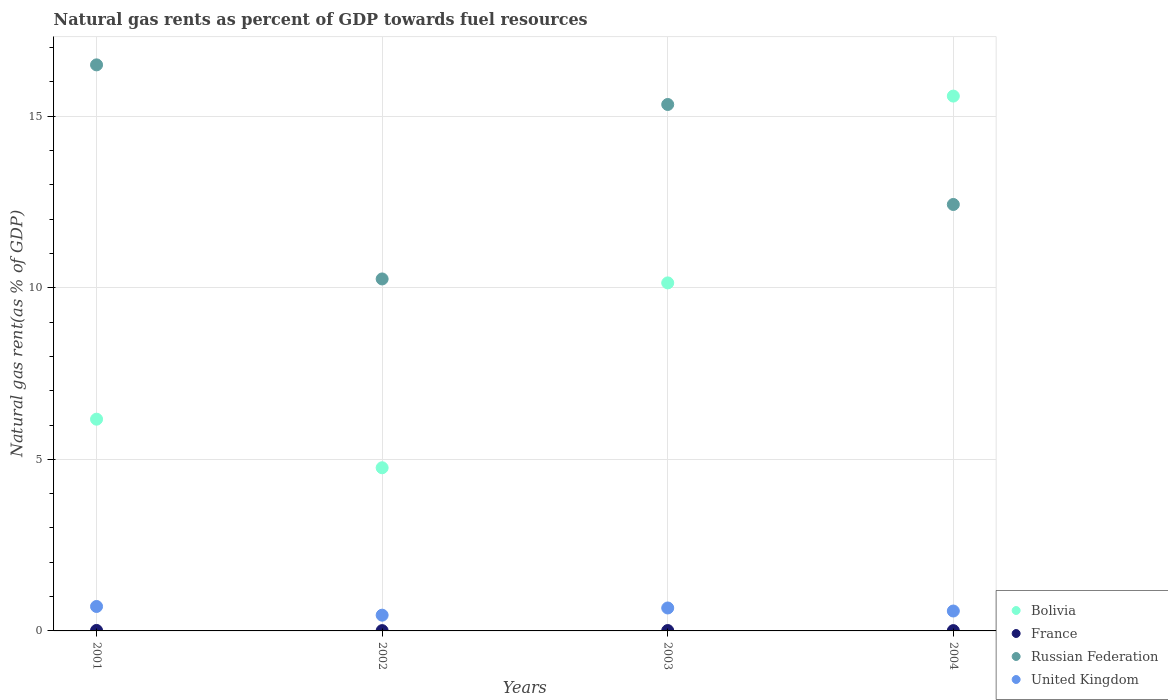Is the number of dotlines equal to the number of legend labels?
Give a very brief answer. Yes. What is the natural gas rent in Bolivia in 2001?
Keep it short and to the point. 6.17. Across all years, what is the maximum natural gas rent in United Kingdom?
Provide a short and direct response. 0.71. Across all years, what is the minimum natural gas rent in United Kingdom?
Your answer should be very brief. 0.46. In which year was the natural gas rent in Russian Federation maximum?
Offer a very short reply. 2001. What is the total natural gas rent in France in the graph?
Make the answer very short. 0.04. What is the difference between the natural gas rent in France in 2001 and that in 2003?
Offer a terse response. 0. What is the difference between the natural gas rent in Russian Federation in 2004 and the natural gas rent in United Kingdom in 2002?
Your answer should be compact. 11.97. What is the average natural gas rent in Bolivia per year?
Provide a short and direct response. 9.16. In the year 2002, what is the difference between the natural gas rent in United Kingdom and natural gas rent in Russian Federation?
Ensure brevity in your answer.  -9.8. In how many years, is the natural gas rent in France greater than 5 %?
Your answer should be very brief. 0. What is the ratio of the natural gas rent in Bolivia in 2002 to that in 2004?
Keep it short and to the point. 0.31. Is the difference between the natural gas rent in United Kingdom in 2003 and 2004 greater than the difference between the natural gas rent in Russian Federation in 2003 and 2004?
Keep it short and to the point. No. What is the difference between the highest and the second highest natural gas rent in France?
Ensure brevity in your answer.  0. What is the difference between the highest and the lowest natural gas rent in Russian Federation?
Keep it short and to the point. 6.24. In how many years, is the natural gas rent in France greater than the average natural gas rent in France taken over all years?
Your response must be concise. 2. Is the sum of the natural gas rent in Bolivia in 2001 and 2004 greater than the maximum natural gas rent in Russian Federation across all years?
Your response must be concise. Yes. Is it the case that in every year, the sum of the natural gas rent in United Kingdom and natural gas rent in Russian Federation  is greater than the sum of natural gas rent in Bolivia and natural gas rent in France?
Your response must be concise. No. Is it the case that in every year, the sum of the natural gas rent in United Kingdom and natural gas rent in France  is greater than the natural gas rent in Russian Federation?
Ensure brevity in your answer.  No. Does the natural gas rent in France monotonically increase over the years?
Provide a succinct answer. No. How many years are there in the graph?
Give a very brief answer. 4. Does the graph contain any zero values?
Make the answer very short. No. Does the graph contain grids?
Your answer should be very brief. Yes. How are the legend labels stacked?
Offer a very short reply. Vertical. What is the title of the graph?
Ensure brevity in your answer.  Natural gas rents as percent of GDP towards fuel resources. What is the label or title of the X-axis?
Make the answer very short. Years. What is the label or title of the Y-axis?
Your answer should be very brief. Natural gas rent(as % of GDP). What is the Natural gas rent(as % of GDP) in Bolivia in 2001?
Make the answer very short. 6.17. What is the Natural gas rent(as % of GDP) in France in 2001?
Give a very brief answer. 0.01. What is the Natural gas rent(as % of GDP) in Russian Federation in 2001?
Offer a terse response. 16.5. What is the Natural gas rent(as % of GDP) of United Kingdom in 2001?
Offer a terse response. 0.71. What is the Natural gas rent(as % of GDP) in Bolivia in 2002?
Provide a succinct answer. 4.76. What is the Natural gas rent(as % of GDP) in France in 2002?
Offer a very short reply. 0.01. What is the Natural gas rent(as % of GDP) of Russian Federation in 2002?
Give a very brief answer. 10.26. What is the Natural gas rent(as % of GDP) in United Kingdom in 2002?
Ensure brevity in your answer.  0.46. What is the Natural gas rent(as % of GDP) of Bolivia in 2003?
Give a very brief answer. 10.14. What is the Natural gas rent(as % of GDP) in France in 2003?
Keep it short and to the point. 0.01. What is the Natural gas rent(as % of GDP) in Russian Federation in 2003?
Make the answer very short. 15.34. What is the Natural gas rent(as % of GDP) in United Kingdom in 2003?
Provide a short and direct response. 0.67. What is the Natural gas rent(as % of GDP) of Bolivia in 2004?
Keep it short and to the point. 15.59. What is the Natural gas rent(as % of GDP) in France in 2004?
Offer a terse response. 0.01. What is the Natural gas rent(as % of GDP) in Russian Federation in 2004?
Make the answer very short. 12.43. What is the Natural gas rent(as % of GDP) of United Kingdom in 2004?
Offer a very short reply. 0.58. Across all years, what is the maximum Natural gas rent(as % of GDP) in Bolivia?
Ensure brevity in your answer.  15.59. Across all years, what is the maximum Natural gas rent(as % of GDP) of France?
Provide a short and direct response. 0.01. Across all years, what is the maximum Natural gas rent(as % of GDP) in Russian Federation?
Give a very brief answer. 16.5. Across all years, what is the maximum Natural gas rent(as % of GDP) in United Kingdom?
Offer a very short reply. 0.71. Across all years, what is the minimum Natural gas rent(as % of GDP) of Bolivia?
Provide a succinct answer. 4.76. Across all years, what is the minimum Natural gas rent(as % of GDP) of France?
Make the answer very short. 0.01. Across all years, what is the minimum Natural gas rent(as % of GDP) in Russian Federation?
Make the answer very short. 10.26. Across all years, what is the minimum Natural gas rent(as % of GDP) of United Kingdom?
Keep it short and to the point. 0.46. What is the total Natural gas rent(as % of GDP) of Bolivia in the graph?
Ensure brevity in your answer.  36.66. What is the total Natural gas rent(as % of GDP) of France in the graph?
Keep it short and to the point. 0.04. What is the total Natural gas rent(as % of GDP) in Russian Federation in the graph?
Your response must be concise. 54.53. What is the total Natural gas rent(as % of GDP) in United Kingdom in the graph?
Your answer should be very brief. 2.42. What is the difference between the Natural gas rent(as % of GDP) in Bolivia in 2001 and that in 2002?
Offer a very short reply. 1.42. What is the difference between the Natural gas rent(as % of GDP) of France in 2001 and that in 2002?
Your answer should be very brief. 0.01. What is the difference between the Natural gas rent(as % of GDP) of Russian Federation in 2001 and that in 2002?
Your answer should be compact. 6.24. What is the difference between the Natural gas rent(as % of GDP) in United Kingdom in 2001 and that in 2002?
Your response must be concise. 0.25. What is the difference between the Natural gas rent(as % of GDP) of Bolivia in 2001 and that in 2003?
Provide a short and direct response. -3.97. What is the difference between the Natural gas rent(as % of GDP) of France in 2001 and that in 2003?
Give a very brief answer. 0. What is the difference between the Natural gas rent(as % of GDP) in Russian Federation in 2001 and that in 2003?
Provide a succinct answer. 1.15. What is the difference between the Natural gas rent(as % of GDP) of United Kingdom in 2001 and that in 2003?
Your answer should be very brief. 0.04. What is the difference between the Natural gas rent(as % of GDP) in Bolivia in 2001 and that in 2004?
Offer a very short reply. -9.42. What is the difference between the Natural gas rent(as % of GDP) of France in 2001 and that in 2004?
Keep it short and to the point. 0.01. What is the difference between the Natural gas rent(as % of GDP) of Russian Federation in 2001 and that in 2004?
Ensure brevity in your answer.  4.07. What is the difference between the Natural gas rent(as % of GDP) of United Kingdom in 2001 and that in 2004?
Keep it short and to the point. 0.13. What is the difference between the Natural gas rent(as % of GDP) of Bolivia in 2002 and that in 2003?
Your answer should be very brief. -5.39. What is the difference between the Natural gas rent(as % of GDP) in France in 2002 and that in 2003?
Provide a succinct answer. -0. What is the difference between the Natural gas rent(as % of GDP) of Russian Federation in 2002 and that in 2003?
Your answer should be compact. -5.08. What is the difference between the Natural gas rent(as % of GDP) in United Kingdom in 2002 and that in 2003?
Ensure brevity in your answer.  -0.21. What is the difference between the Natural gas rent(as % of GDP) in Bolivia in 2002 and that in 2004?
Ensure brevity in your answer.  -10.83. What is the difference between the Natural gas rent(as % of GDP) in Russian Federation in 2002 and that in 2004?
Ensure brevity in your answer.  -2.17. What is the difference between the Natural gas rent(as % of GDP) in United Kingdom in 2002 and that in 2004?
Provide a succinct answer. -0.12. What is the difference between the Natural gas rent(as % of GDP) in Bolivia in 2003 and that in 2004?
Offer a very short reply. -5.44. What is the difference between the Natural gas rent(as % of GDP) in France in 2003 and that in 2004?
Your response must be concise. 0. What is the difference between the Natural gas rent(as % of GDP) in Russian Federation in 2003 and that in 2004?
Provide a short and direct response. 2.91. What is the difference between the Natural gas rent(as % of GDP) of United Kingdom in 2003 and that in 2004?
Provide a succinct answer. 0.09. What is the difference between the Natural gas rent(as % of GDP) in Bolivia in 2001 and the Natural gas rent(as % of GDP) in France in 2002?
Provide a succinct answer. 6.16. What is the difference between the Natural gas rent(as % of GDP) of Bolivia in 2001 and the Natural gas rent(as % of GDP) of Russian Federation in 2002?
Your response must be concise. -4.09. What is the difference between the Natural gas rent(as % of GDP) in Bolivia in 2001 and the Natural gas rent(as % of GDP) in United Kingdom in 2002?
Provide a succinct answer. 5.71. What is the difference between the Natural gas rent(as % of GDP) of France in 2001 and the Natural gas rent(as % of GDP) of Russian Federation in 2002?
Offer a very short reply. -10.24. What is the difference between the Natural gas rent(as % of GDP) of France in 2001 and the Natural gas rent(as % of GDP) of United Kingdom in 2002?
Offer a terse response. -0.44. What is the difference between the Natural gas rent(as % of GDP) of Russian Federation in 2001 and the Natural gas rent(as % of GDP) of United Kingdom in 2002?
Keep it short and to the point. 16.04. What is the difference between the Natural gas rent(as % of GDP) in Bolivia in 2001 and the Natural gas rent(as % of GDP) in France in 2003?
Keep it short and to the point. 6.16. What is the difference between the Natural gas rent(as % of GDP) of Bolivia in 2001 and the Natural gas rent(as % of GDP) of Russian Federation in 2003?
Give a very brief answer. -9.17. What is the difference between the Natural gas rent(as % of GDP) in Bolivia in 2001 and the Natural gas rent(as % of GDP) in United Kingdom in 2003?
Provide a succinct answer. 5.5. What is the difference between the Natural gas rent(as % of GDP) of France in 2001 and the Natural gas rent(as % of GDP) of Russian Federation in 2003?
Your answer should be very brief. -15.33. What is the difference between the Natural gas rent(as % of GDP) of France in 2001 and the Natural gas rent(as % of GDP) of United Kingdom in 2003?
Make the answer very short. -0.65. What is the difference between the Natural gas rent(as % of GDP) of Russian Federation in 2001 and the Natural gas rent(as % of GDP) of United Kingdom in 2003?
Offer a terse response. 15.83. What is the difference between the Natural gas rent(as % of GDP) in Bolivia in 2001 and the Natural gas rent(as % of GDP) in France in 2004?
Provide a short and direct response. 6.16. What is the difference between the Natural gas rent(as % of GDP) in Bolivia in 2001 and the Natural gas rent(as % of GDP) in Russian Federation in 2004?
Provide a short and direct response. -6.26. What is the difference between the Natural gas rent(as % of GDP) in Bolivia in 2001 and the Natural gas rent(as % of GDP) in United Kingdom in 2004?
Make the answer very short. 5.59. What is the difference between the Natural gas rent(as % of GDP) in France in 2001 and the Natural gas rent(as % of GDP) in Russian Federation in 2004?
Provide a succinct answer. -12.41. What is the difference between the Natural gas rent(as % of GDP) in France in 2001 and the Natural gas rent(as % of GDP) in United Kingdom in 2004?
Give a very brief answer. -0.57. What is the difference between the Natural gas rent(as % of GDP) of Russian Federation in 2001 and the Natural gas rent(as % of GDP) of United Kingdom in 2004?
Your answer should be very brief. 15.92. What is the difference between the Natural gas rent(as % of GDP) of Bolivia in 2002 and the Natural gas rent(as % of GDP) of France in 2003?
Offer a terse response. 4.74. What is the difference between the Natural gas rent(as % of GDP) in Bolivia in 2002 and the Natural gas rent(as % of GDP) in Russian Federation in 2003?
Offer a very short reply. -10.59. What is the difference between the Natural gas rent(as % of GDP) in Bolivia in 2002 and the Natural gas rent(as % of GDP) in United Kingdom in 2003?
Ensure brevity in your answer.  4.09. What is the difference between the Natural gas rent(as % of GDP) of France in 2002 and the Natural gas rent(as % of GDP) of Russian Federation in 2003?
Your answer should be very brief. -15.33. What is the difference between the Natural gas rent(as % of GDP) in France in 2002 and the Natural gas rent(as % of GDP) in United Kingdom in 2003?
Offer a terse response. -0.66. What is the difference between the Natural gas rent(as % of GDP) of Russian Federation in 2002 and the Natural gas rent(as % of GDP) of United Kingdom in 2003?
Your answer should be compact. 9.59. What is the difference between the Natural gas rent(as % of GDP) of Bolivia in 2002 and the Natural gas rent(as % of GDP) of France in 2004?
Offer a very short reply. 4.75. What is the difference between the Natural gas rent(as % of GDP) of Bolivia in 2002 and the Natural gas rent(as % of GDP) of Russian Federation in 2004?
Offer a very short reply. -7.67. What is the difference between the Natural gas rent(as % of GDP) of Bolivia in 2002 and the Natural gas rent(as % of GDP) of United Kingdom in 2004?
Keep it short and to the point. 4.18. What is the difference between the Natural gas rent(as % of GDP) in France in 2002 and the Natural gas rent(as % of GDP) in Russian Federation in 2004?
Give a very brief answer. -12.42. What is the difference between the Natural gas rent(as % of GDP) of France in 2002 and the Natural gas rent(as % of GDP) of United Kingdom in 2004?
Your answer should be very brief. -0.57. What is the difference between the Natural gas rent(as % of GDP) of Russian Federation in 2002 and the Natural gas rent(as % of GDP) of United Kingdom in 2004?
Keep it short and to the point. 9.68. What is the difference between the Natural gas rent(as % of GDP) of Bolivia in 2003 and the Natural gas rent(as % of GDP) of France in 2004?
Your answer should be very brief. 10.13. What is the difference between the Natural gas rent(as % of GDP) in Bolivia in 2003 and the Natural gas rent(as % of GDP) in Russian Federation in 2004?
Your answer should be very brief. -2.29. What is the difference between the Natural gas rent(as % of GDP) in Bolivia in 2003 and the Natural gas rent(as % of GDP) in United Kingdom in 2004?
Offer a terse response. 9.56. What is the difference between the Natural gas rent(as % of GDP) in France in 2003 and the Natural gas rent(as % of GDP) in Russian Federation in 2004?
Keep it short and to the point. -12.42. What is the difference between the Natural gas rent(as % of GDP) of France in 2003 and the Natural gas rent(as % of GDP) of United Kingdom in 2004?
Give a very brief answer. -0.57. What is the difference between the Natural gas rent(as % of GDP) in Russian Federation in 2003 and the Natural gas rent(as % of GDP) in United Kingdom in 2004?
Your answer should be compact. 14.76. What is the average Natural gas rent(as % of GDP) of Bolivia per year?
Offer a terse response. 9.16. What is the average Natural gas rent(as % of GDP) in France per year?
Your answer should be compact. 0.01. What is the average Natural gas rent(as % of GDP) in Russian Federation per year?
Offer a terse response. 13.63. What is the average Natural gas rent(as % of GDP) of United Kingdom per year?
Provide a succinct answer. 0.61. In the year 2001, what is the difference between the Natural gas rent(as % of GDP) in Bolivia and Natural gas rent(as % of GDP) in France?
Provide a short and direct response. 6.16. In the year 2001, what is the difference between the Natural gas rent(as % of GDP) in Bolivia and Natural gas rent(as % of GDP) in Russian Federation?
Ensure brevity in your answer.  -10.33. In the year 2001, what is the difference between the Natural gas rent(as % of GDP) of Bolivia and Natural gas rent(as % of GDP) of United Kingdom?
Your answer should be very brief. 5.46. In the year 2001, what is the difference between the Natural gas rent(as % of GDP) in France and Natural gas rent(as % of GDP) in Russian Federation?
Give a very brief answer. -16.48. In the year 2001, what is the difference between the Natural gas rent(as % of GDP) of France and Natural gas rent(as % of GDP) of United Kingdom?
Offer a terse response. -0.7. In the year 2001, what is the difference between the Natural gas rent(as % of GDP) of Russian Federation and Natural gas rent(as % of GDP) of United Kingdom?
Your answer should be very brief. 15.78. In the year 2002, what is the difference between the Natural gas rent(as % of GDP) of Bolivia and Natural gas rent(as % of GDP) of France?
Provide a succinct answer. 4.75. In the year 2002, what is the difference between the Natural gas rent(as % of GDP) of Bolivia and Natural gas rent(as % of GDP) of Russian Federation?
Ensure brevity in your answer.  -5.5. In the year 2002, what is the difference between the Natural gas rent(as % of GDP) of Bolivia and Natural gas rent(as % of GDP) of United Kingdom?
Offer a terse response. 4.3. In the year 2002, what is the difference between the Natural gas rent(as % of GDP) in France and Natural gas rent(as % of GDP) in Russian Federation?
Ensure brevity in your answer.  -10.25. In the year 2002, what is the difference between the Natural gas rent(as % of GDP) of France and Natural gas rent(as % of GDP) of United Kingdom?
Provide a short and direct response. -0.45. In the year 2002, what is the difference between the Natural gas rent(as % of GDP) of Russian Federation and Natural gas rent(as % of GDP) of United Kingdom?
Your answer should be very brief. 9.8. In the year 2003, what is the difference between the Natural gas rent(as % of GDP) of Bolivia and Natural gas rent(as % of GDP) of France?
Offer a very short reply. 10.13. In the year 2003, what is the difference between the Natural gas rent(as % of GDP) in Bolivia and Natural gas rent(as % of GDP) in Russian Federation?
Your response must be concise. -5.2. In the year 2003, what is the difference between the Natural gas rent(as % of GDP) in Bolivia and Natural gas rent(as % of GDP) in United Kingdom?
Offer a very short reply. 9.47. In the year 2003, what is the difference between the Natural gas rent(as % of GDP) in France and Natural gas rent(as % of GDP) in Russian Federation?
Offer a very short reply. -15.33. In the year 2003, what is the difference between the Natural gas rent(as % of GDP) in France and Natural gas rent(as % of GDP) in United Kingdom?
Make the answer very short. -0.66. In the year 2003, what is the difference between the Natural gas rent(as % of GDP) in Russian Federation and Natural gas rent(as % of GDP) in United Kingdom?
Provide a short and direct response. 14.67. In the year 2004, what is the difference between the Natural gas rent(as % of GDP) of Bolivia and Natural gas rent(as % of GDP) of France?
Offer a very short reply. 15.58. In the year 2004, what is the difference between the Natural gas rent(as % of GDP) of Bolivia and Natural gas rent(as % of GDP) of Russian Federation?
Your answer should be very brief. 3.16. In the year 2004, what is the difference between the Natural gas rent(as % of GDP) of Bolivia and Natural gas rent(as % of GDP) of United Kingdom?
Keep it short and to the point. 15.01. In the year 2004, what is the difference between the Natural gas rent(as % of GDP) in France and Natural gas rent(as % of GDP) in Russian Federation?
Provide a succinct answer. -12.42. In the year 2004, what is the difference between the Natural gas rent(as % of GDP) of France and Natural gas rent(as % of GDP) of United Kingdom?
Your response must be concise. -0.57. In the year 2004, what is the difference between the Natural gas rent(as % of GDP) in Russian Federation and Natural gas rent(as % of GDP) in United Kingdom?
Provide a short and direct response. 11.85. What is the ratio of the Natural gas rent(as % of GDP) in Bolivia in 2001 to that in 2002?
Your answer should be compact. 1.3. What is the ratio of the Natural gas rent(as % of GDP) of France in 2001 to that in 2002?
Your response must be concise. 1.59. What is the ratio of the Natural gas rent(as % of GDP) in Russian Federation in 2001 to that in 2002?
Your answer should be very brief. 1.61. What is the ratio of the Natural gas rent(as % of GDP) in United Kingdom in 2001 to that in 2002?
Provide a succinct answer. 1.55. What is the ratio of the Natural gas rent(as % of GDP) of Bolivia in 2001 to that in 2003?
Provide a succinct answer. 0.61. What is the ratio of the Natural gas rent(as % of GDP) in France in 2001 to that in 2003?
Your answer should be very brief. 1.3. What is the ratio of the Natural gas rent(as % of GDP) in Russian Federation in 2001 to that in 2003?
Offer a terse response. 1.08. What is the ratio of the Natural gas rent(as % of GDP) in United Kingdom in 2001 to that in 2003?
Your answer should be very brief. 1.07. What is the ratio of the Natural gas rent(as % of GDP) in Bolivia in 2001 to that in 2004?
Provide a short and direct response. 0.4. What is the ratio of the Natural gas rent(as % of GDP) of France in 2001 to that in 2004?
Provide a short and direct response. 1.59. What is the ratio of the Natural gas rent(as % of GDP) of Russian Federation in 2001 to that in 2004?
Provide a succinct answer. 1.33. What is the ratio of the Natural gas rent(as % of GDP) of United Kingdom in 2001 to that in 2004?
Ensure brevity in your answer.  1.23. What is the ratio of the Natural gas rent(as % of GDP) in Bolivia in 2002 to that in 2003?
Ensure brevity in your answer.  0.47. What is the ratio of the Natural gas rent(as % of GDP) of France in 2002 to that in 2003?
Your answer should be very brief. 0.82. What is the ratio of the Natural gas rent(as % of GDP) of Russian Federation in 2002 to that in 2003?
Keep it short and to the point. 0.67. What is the ratio of the Natural gas rent(as % of GDP) in United Kingdom in 2002 to that in 2003?
Offer a terse response. 0.69. What is the ratio of the Natural gas rent(as % of GDP) of Bolivia in 2002 to that in 2004?
Offer a very short reply. 0.31. What is the ratio of the Natural gas rent(as % of GDP) in Russian Federation in 2002 to that in 2004?
Offer a very short reply. 0.83. What is the ratio of the Natural gas rent(as % of GDP) of United Kingdom in 2002 to that in 2004?
Offer a very short reply. 0.79. What is the ratio of the Natural gas rent(as % of GDP) of Bolivia in 2003 to that in 2004?
Provide a succinct answer. 0.65. What is the ratio of the Natural gas rent(as % of GDP) in France in 2003 to that in 2004?
Offer a very short reply. 1.22. What is the ratio of the Natural gas rent(as % of GDP) in Russian Federation in 2003 to that in 2004?
Ensure brevity in your answer.  1.23. What is the ratio of the Natural gas rent(as % of GDP) in United Kingdom in 2003 to that in 2004?
Ensure brevity in your answer.  1.15. What is the difference between the highest and the second highest Natural gas rent(as % of GDP) in Bolivia?
Make the answer very short. 5.44. What is the difference between the highest and the second highest Natural gas rent(as % of GDP) of France?
Offer a terse response. 0. What is the difference between the highest and the second highest Natural gas rent(as % of GDP) in Russian Federation?
Provide a short and direct response. 1.15. What is the difference between the highest and the second highest Natural gas rent(as % of GDP) in United Kingdom?
Provide a short and direct response. 0.04. What is the difference between the highest and the lowest Natural gas rent(as % of GDP) of Bolivia?
Your answer should be compact. 10.83. What is the difference between the highest and the lowest Natural gas rent(as % of GDP) in France?
Keep it short and to the point. 0.01. What is the difference between the highest and the lowest Natural gas rent(as % of GDP) of Russian Federation?
Make the answer very short. 6.24. What is the difference between the highest and the lowest Natural gas rent(as % of GDP) in United Kingdom?
Offer a terse response. 0.25. 